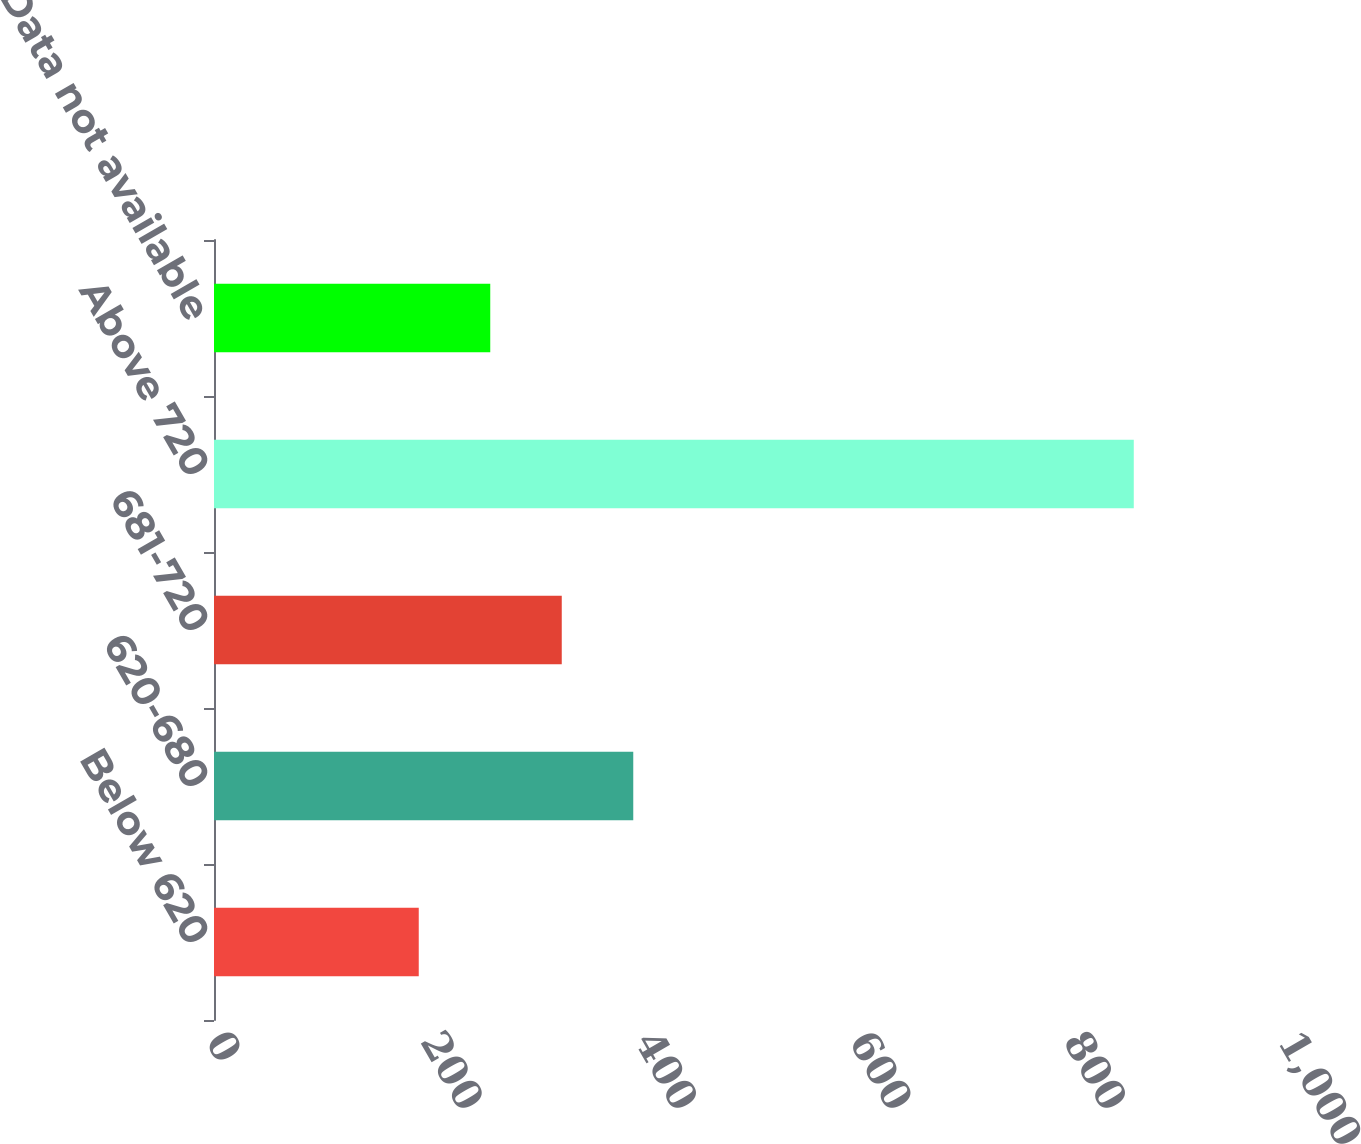Convert chart to OTSL. <chart><loc_0><loc_0><loc_500><loc_500><bar_chart><fcel>Below 620<fcel>620-680<fcel>681-720<fcel>Above 720<fcel>Data not available<nl><fcel>191<fcel>391.1<fcel>324.4<fcel>858<fcel>257.7<nl></chart> 